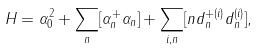<formula> <loc_0><loc_0><loc_500><loc_500>H = \alpha _ { 0 } ^ { 2 } + \sum _ { n } [ \alpha ^ { + } _ { n } \alpha _ { n } ] + \sum _ { i , { n } } [ n d ^ { + ( i ) } _ { n } d ^ { ( i ) } _ { n } ] ,</formula> 